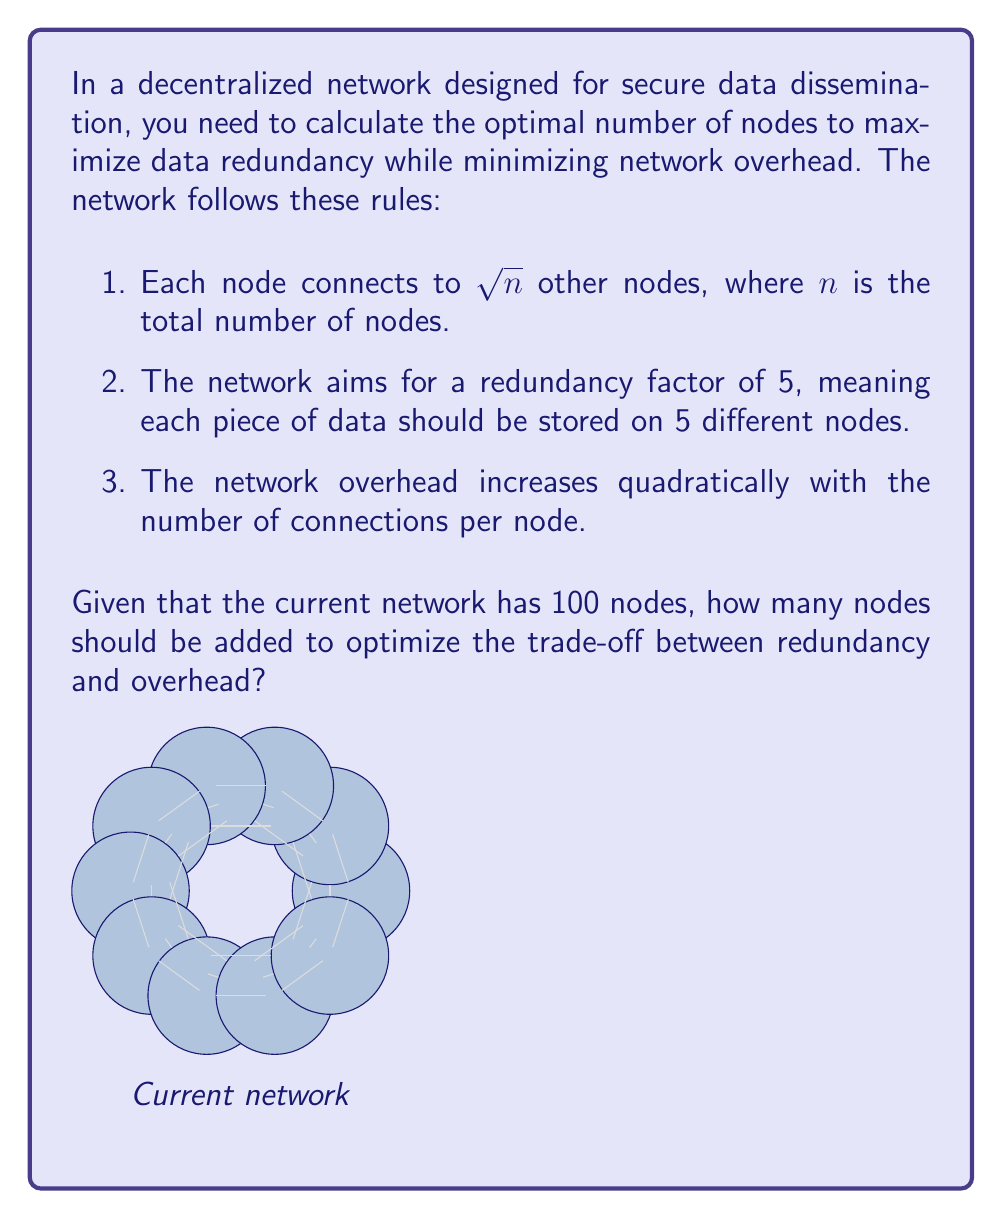Solve this math problem. Let's approach this step-by-step:

1) First, we need to define our optimization function. We want to maximize redundancy while minimizing overhead. Let's call this function $f(n)$:

   $$f(n) = \frac{\text{redundancy}}{\text{overhead}}$$

2) Redundancy is proportional to the number of connections per node, which is $\sqrt{n}$. We want this to be as close to 5 as possible:

   $$\text{redundancy} = |\sqrt{n} - 5|$$

3) Overhead increases quadratically with the number of connections per node:

   $$\text{overhead} = (\sqrt{n})^2 = n$$

4) So our optimization function becomes:

   $$f(n) = \frac{|\sqrt{n} - 5|}{n}$$

5) To find the optimal value, we need to minimize this function. We can do this by finding where its derivative equals zero:

   $$f'(n) = \frac{n \cdot \frac{1}{2\sqrt{n}} - |\sqrt{n} - 5|}{n^2} = 0$$

6) Solving this equation:

   $$\frac{\sqrt{n}}{2} - |\sqrt{n} - 5| = 0$$
   $$\sqrt{n} = 10$$
   $$n = 100$$

7) This means the optimal number of nodes is 100. Since we already have 100 nodes, we don't need to add any more nodes to optimize the network.

However, in practice, we might want to add some redundancy to account for node failures or network partitions. A common approach is to add about 10% more nodes than the theoretical optimum.

So, a practical recommendation would be to add 10 nodes (10% of 100) to the network.
Answer: 10 nodes 